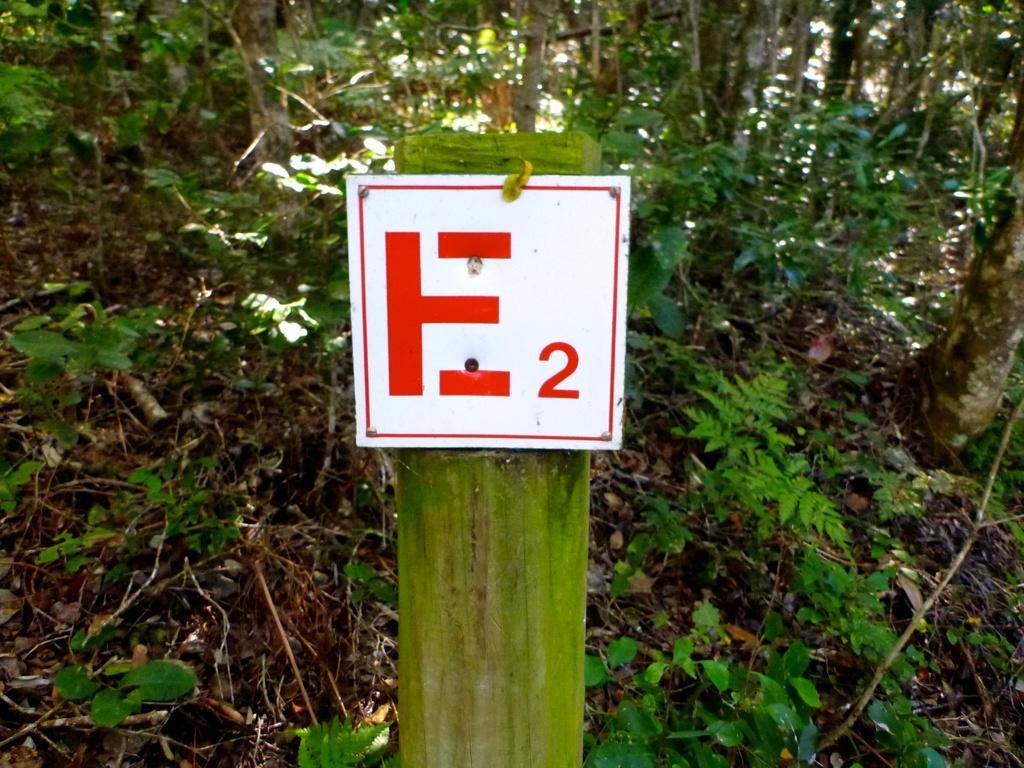In one or two sentences, can you explain what this image depicts? In the center of the image we can see a board. In the background there are trees and plants. 